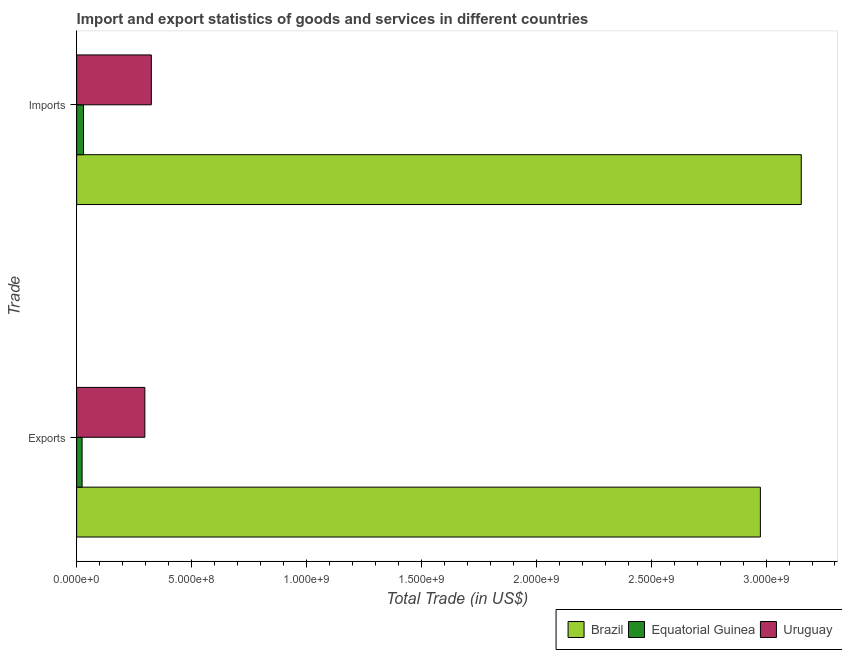How many groups of bars are there?
Your answer should be very brief. 2. Are the number of bars per tick equal to the number of legend labels?
Ensure brevity in your answer.  Yes. Are the number of bars on each tick of the Y-axis equal?
Keep it short and to the point. Yes. How many bars are there on the 2nd tick from the top?
Provide a succinct answer. 3. How many bars are there on the 1st tick from the bottom?
Your answer should be very brief. 3. What is the label of the 2nd group of bars from the top?
Keep it short and to the point. Exports. What is the imports of goods and services in Uruguay?
Offer a very short reply. 3.25e+08. Across all countries, what is the maximum export of goods and services?
Make the answer very short. 2.98e+09. Across all countries, what is the minimum imports of goods and services?
Your response must be concise. 2.99e+07. In which country was the imports of goods and services maximum?
Your response must be concise. Brazil. In which country was the export of goods and services minimum?
Offer a terse response. Equatorial Guinea. What is the total imports of goods and services in the graph?
Your response must be concise. 3.51e+09. What is the difference between the imports of goods and services in Uruguay and that in Brazil?
Provide a succinct answer. -2.83e+09. What is the difference between the export of goods and services in Uruguay and the imports of goods and services in Equatorial Guinea?
Ensure brevity in your answer.  2.67e+08. What is the average export of goods and services per country?
Provide a short and direct response. 1.10e+09. What is the difference between the export of goods and services and imports of goods and services in Uruguay?
Offer a very short reply. -2.82e+07. In how many countries, is the imports of goods and services greater than 2500000000 US$?
Offer a very short reply. 1. What is the ratio of the imports of goods and services in Equatorial Guinea to that in Brazil?
Your response must be concise. 0.01. Is the imports of goods and services in Equatorial Guinea less than that in Brazil?
Make the answer very short. Yes. In how many countries, is the imports of goods and services greater than the average imports of goods and services taken over all countries?
Make the answer very short. 1. What does the 2nd bar from the bottom in Exports represents?
Your answer should be very brief. Equatorial Guinea. Are all the bars in the graph horizontal?
Offer a very short reply. Yes. What is the difference between two consecutive major ticks on the X-axis?
Your answer should be compact. 5.00e+08. Are the values on the major ticks of X-axis written in scientific E-notation?
Provide a succinct answer. Yes. Does the graph contain grids?
Ensure brevity in your answer.  No. How are the legend labels stacked?
Provide a short and direct response. Horizontal. What is the title of the graph?
Your response must be concise. Import and export statistics of goods and services in different countries. Does "Guyana" appear as one of the legend labels in the graph?
Offer a terse response. No. What is the label or title of the X-axis?
Offer a very short reply. Total Trade (in US$). What is the label or title of the Y-axis?
Provide a succinct answer. Trade. What is the Total Trade (in US$) of Brazil in Exports?
Provide a short and direct response. 2.98e+09. What is the Total Trade (in US$) of Equatorial Guinea in Exports?
Your response must be concise. 2.37e+07. What is the Total Trade (in US$) of Uruguay in Exports?
Ensure brevity in your answer.  2.97e+08. What is the Total Trade (in US$) in Brazil in Imports?
Ensure brevity in your answer.  3.15e+09. What is the Total Trade (in US$) of Equatorial Guinea in Imports?
Make the answer very short. 2.99e+07. What is the Total Trade (in US$) in Uruguay in Imports?
Make the answer very short. 3.25e+08. Across all Trade, what is the maximum Total Trade (in US$) in Brazil?
Your answer should be very brief. 3.15e+09. Across all Trade, what is the maximum Total Trade (in US$) in Equatorial Guinea?
Your answer should be very brief. 2.99e+07. Across all Trade, what is the maximum Total Trade (in US$) of Uruguay?
Your response must be concise. 3.25e+08. Across all Trade, what is the minimum Total Trade (in US$) in Brazil?
Provide a succinct answer. 2.98e+09. Across all Trade, what is the minimum Total Trade (in US$) of Equatorial Guinea?
Your answer should be compact. 2.37e+07. Across all Trade, what is the minimum Total Trade (in US$) in Uruguay?
Provide a succinct answer. 2.97e+08. What is the total Total Trade (in US$) of Brazil in the graph?
Provide a short and direct response. 6.13e+09. What is the total Total Trade (in US$) of Equatorial Guinea in the graph?
Your answer should be compact. 5.36e+07. What is the total Total Trade (in US$) of Uruguay in the graph?
Provide a short and direct response. 6.22e+08. What is the difference between the Total Trade (in US$) in Brazil in Exports and that in Imports?
Your answer should be very brief. -1.78e+08. What is the difference between the Total Trade (in US$) of Equatorial Guinea in Exports and that in Imports?
Offer a terse response. -6.23e+06. What is the difference between the Total Trade (in US$) of Uruguay in Exports and that in Imports?
Keep it short and to the point. -2.82e+07. What is the difference between the Total Trade (in US$) of Brazil in Exports and the Total Trade (in US$) of Equatorial Guinea in Imports?
Give a very brief answer. 2.95e+09. What is the difference between the Total Trade (in US$) in Brazil in Exports and the Total Trade (in US$) in Uruguay in Imports?
Give a very brief answer. 2.65e+09. What is the difference between the Total Trade (in US$) of Equatorial Guinea in Exports and the Total Trade (in US$) of Uruguay in Imports?
Your answer should be very brief. -3.01e+08. What is the average Total Trade (in US$) of Brazil per Trade?
Make the answer very short. 3.06e+09. What is the average Total Trade (in US$) of Equatorial Guinea per Trade?
Your response must be concise. 2.68e+07. What is the average Total Trade (in US$) of Uruguay per Trade?
Ensure brevity in your answer.  3.11e+08. What is the difference between the Total Trade (in US$) in Brazil and Total Trade (in US$) in Equatorial Guinea in Exports?
Provide a succinct answer. 2.95e+09. What is the difference between the Total Trade (in US$) of Brazil and Total Trade (in US$) of Uruguay in Exports?
Offer a very short reply. 2.68e+09. What is the difference between the Total Trade (in US$) in Equatorial Guinea and Total Trade (in US$) in Uruguay in Exports?
Make the answer very short. -2.73e+08. What is the difference between the Total Trade (in US$) of Brazil and Total Trade (in US$) of Equatorial Guinea in Imports?
Your answer should be very brief. 3.12e+09. What is the difference between the Total Trade (in US$) of Brazil and Total Trade (in US$) of Uruguay in Imports?
Ensure brevity in your answer.  2.83e+09. What is the difference between the Total Trade (in US$) in Equatorial Guinea and Total Trade (in US$) in Uruguay in Imports?
Your answer should be compact. -2.95e+08. What is the ratio of the Total Trade (in US$) of Brazil in Exports to that in Imports?
Give a very brief answer. 0.94. What is the ratio of the Total Trade (in US$) of Equatorial Guinea in Exports to that in Imports?
Your answer should be very brief. 0.79. What is the ratio of the Total Trade (in US$) of Uruguay in Exports to that in Imports?
Make the answer very short. 0.91. What is the difference between the highest and the second highest Total Trade (in US$) in Brazil?
Your answer should be compact. 1.78e+08. What is the difference between the highest and the second highest Total Trade (in US$) in Equatorial Guinea?
Your answer should be very brief. 6.23e+06. What is the difference between the highest and the second highest Total Trade (in US$) of Uruguay?
Ensure brevity in your answer.  2.82e+07. What is the difference between the highest and the lowest Total Trade (in US$) in Brazil?
Provide a succinct answer. 1.78e+08. What is the difference between the highest and the lowest Total Trade (in US$) in Equatorial Guinea?
Offer a very short reply. 6.23e+06. What is the difference between the highest and the lowest Total Trade (in US$) of Uruguay?
Your answer should be very brief. 2.82e+07. 